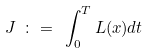<formula> <loc_0><loc_0><loc_500><loc_500>J \ \colon = \ \int _ { 0 } ^ { T } L ( x ) d t</formula> 